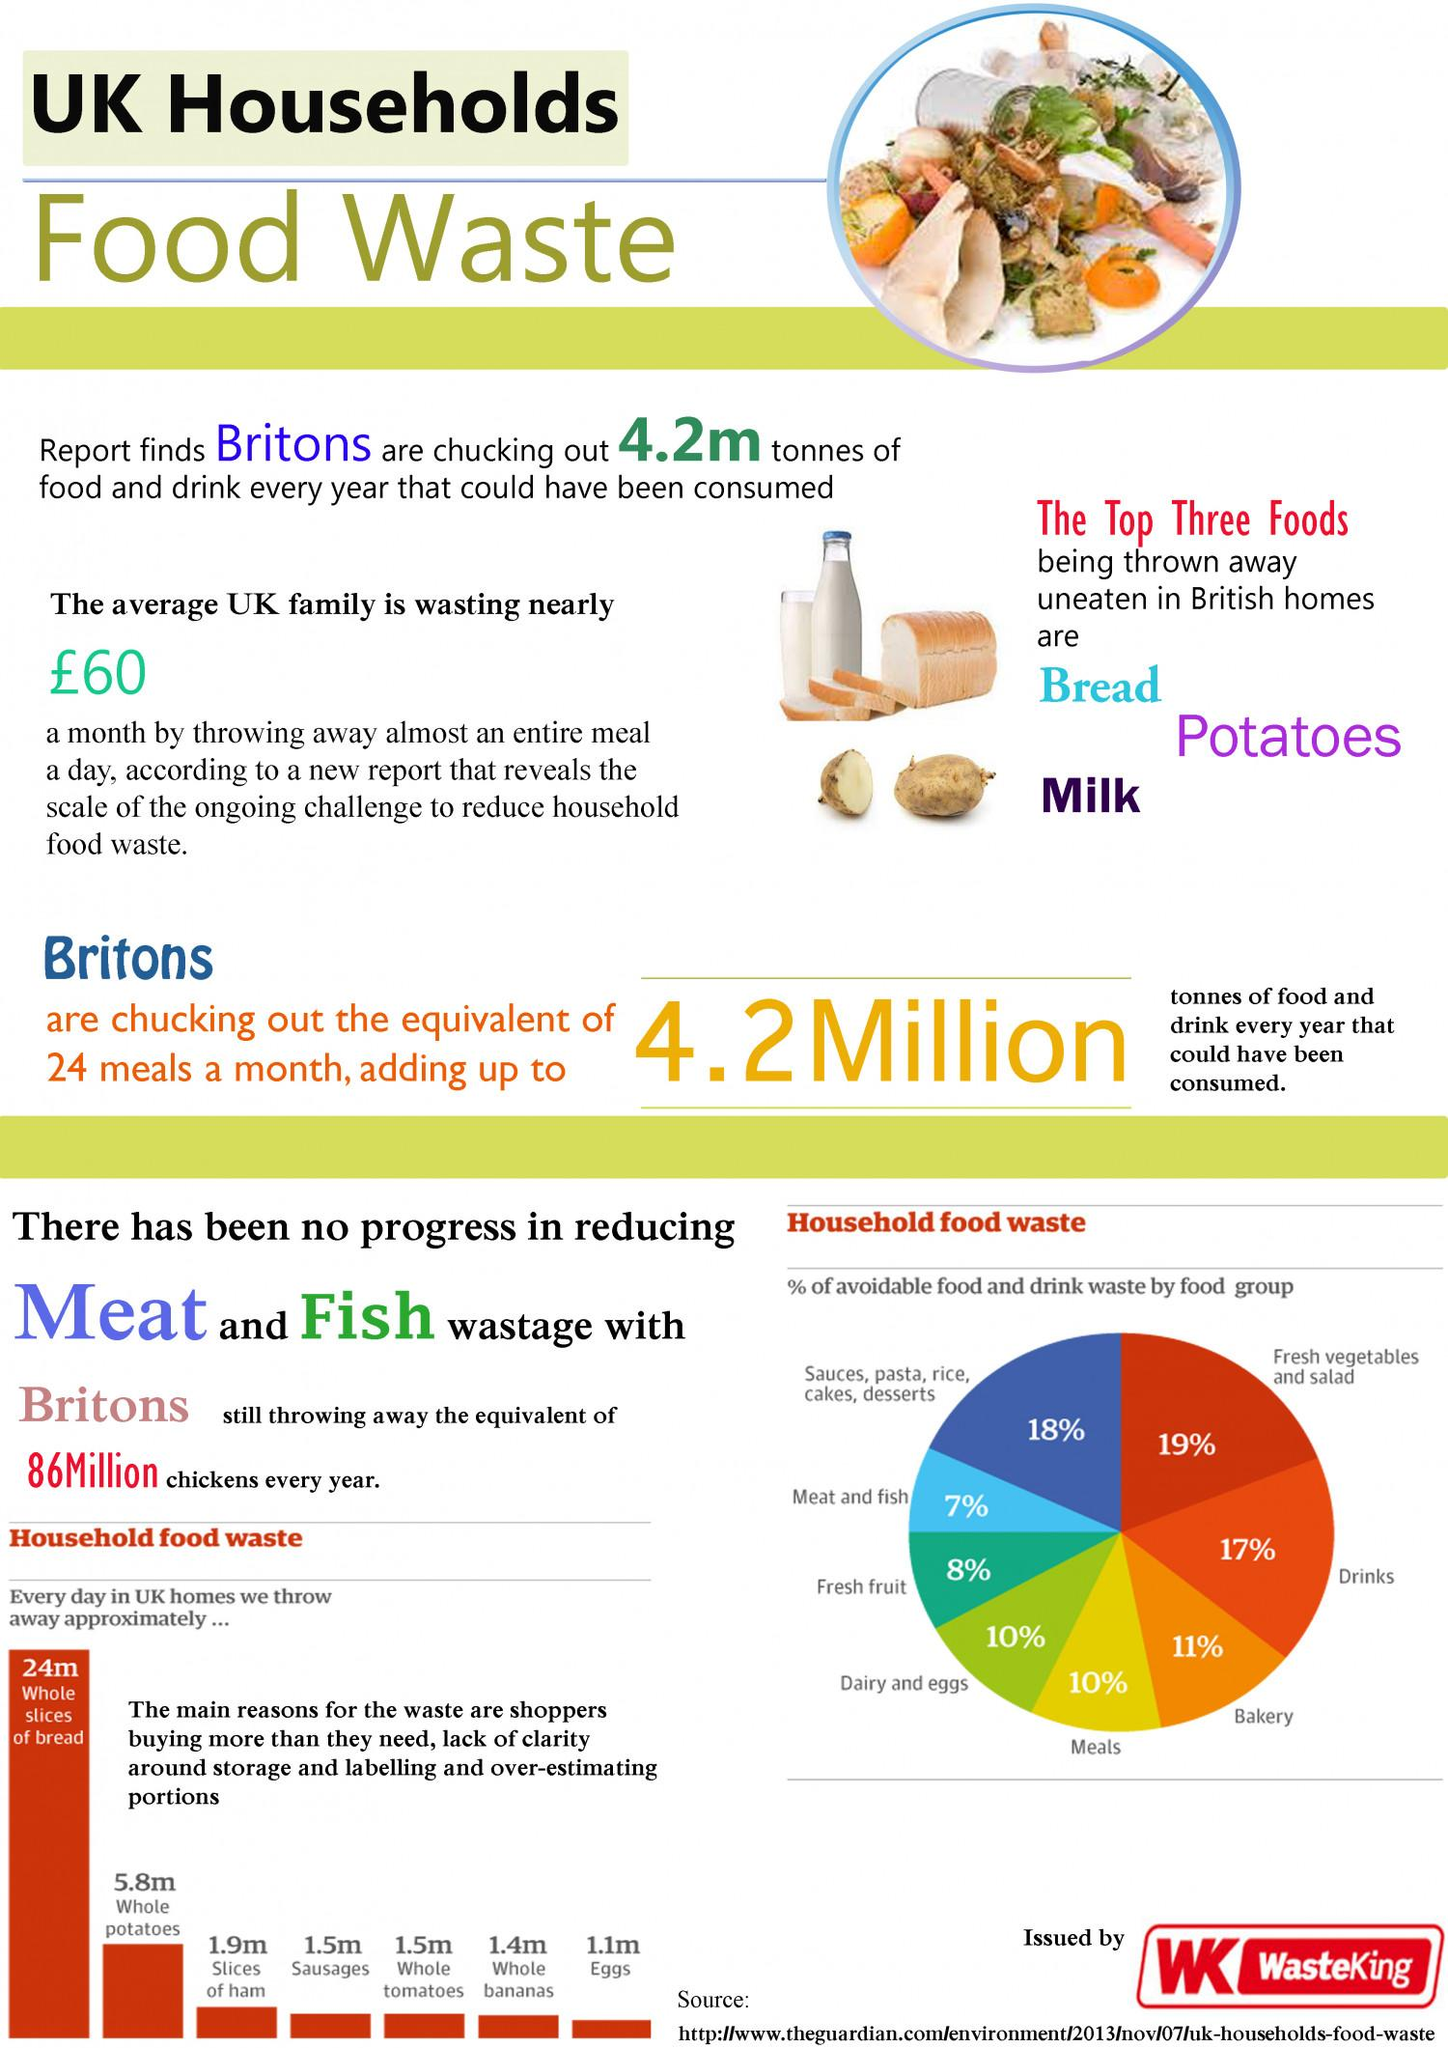Mention a couple of crucial points in this snapshot. Of the household food items, those with waste quantities less than 1.5 meters comprise 2. The major food items that are prevalent in UK households and are frequently wasted include bread, potatoes, and milk. The color yellow is used to indicate the waste percentage of meals. The third most commonly wasted household food item in the UK is slices of ham. The color yellow, white, orange, and black are used to indicate the waste percentage of bakery products. 